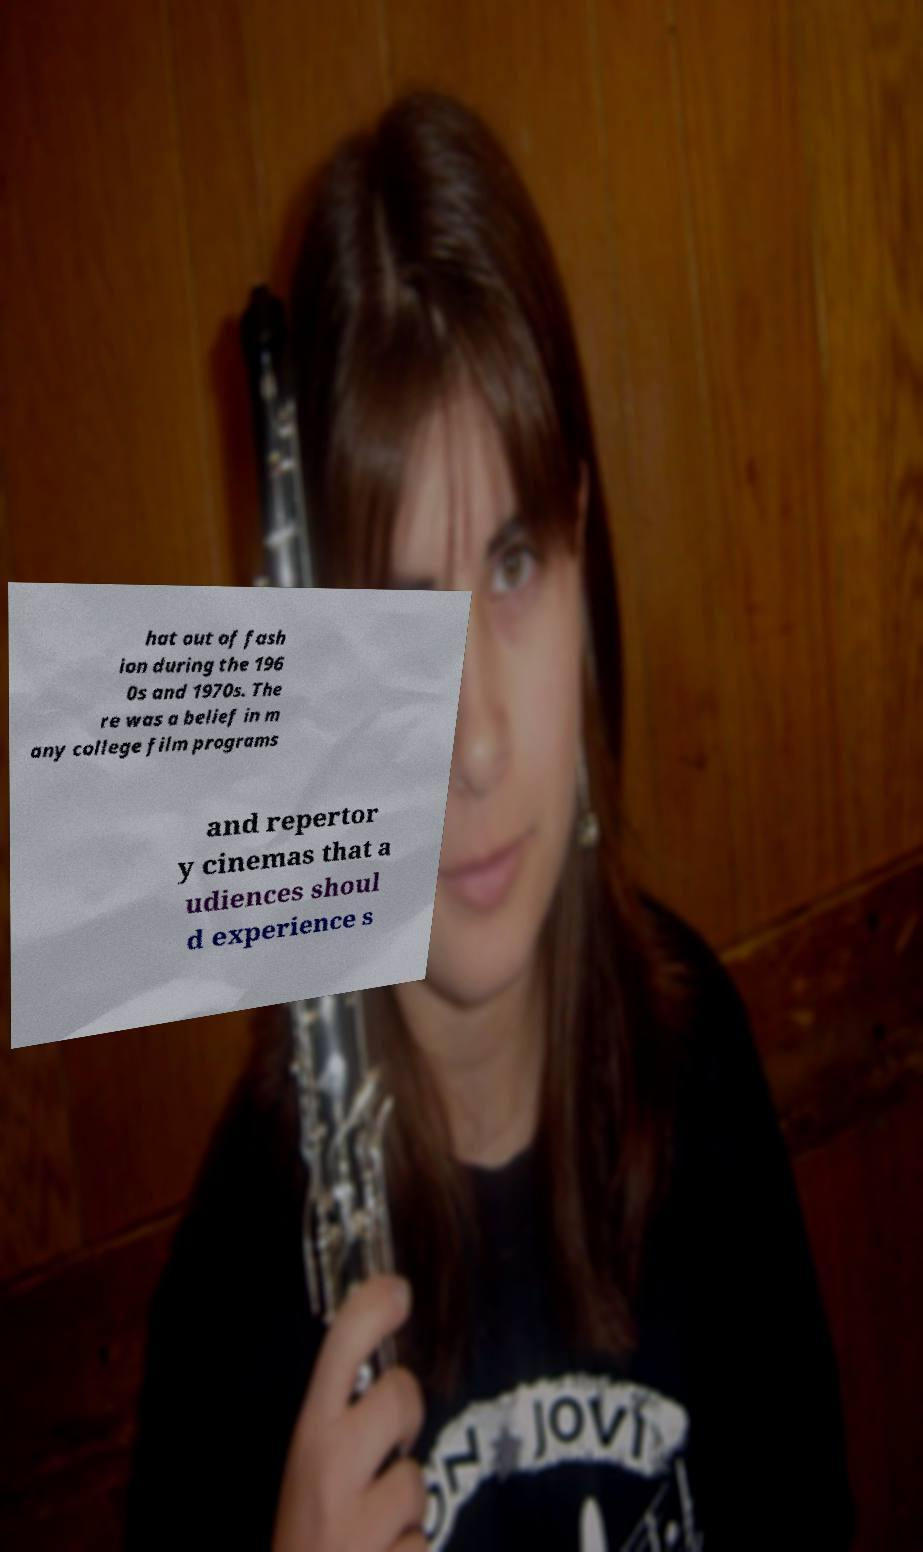Can you read and provide the text displayed in the image?This photo seems to have some interesting text. Can you extract and type it out for me? hat out of fash ion during the 196 0s and 1970s. The re was a belief in m any college film programs and repertor y cinemas that a udiences shoul d experience s 